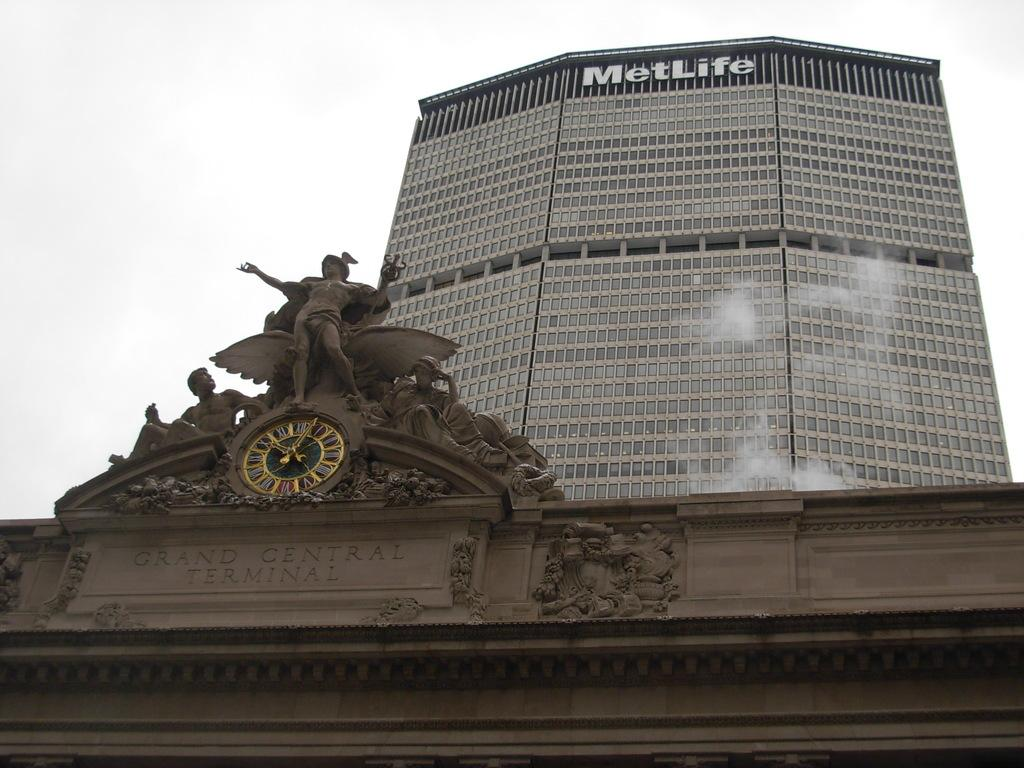What type of artwork can be seen in the image? There are sculptures in the image. What can be found on the wall of a building in the image? There is a clock on the wall of a building in the image. What is present on the wall of a building in the background of the image? There is a hoarding on the wall of a building in the background of the image. What is visible in the sky in the background of the image? There are clouds in the sky in the background of the image. What type of grain is being harvested in the image? There is no grain present in the image; it features sculptures, a clock, a hoarding, and clouds. Can you describe the air quality in the image? The image does not provide any information about the air quality; it only shows sculptures, a clock, a hoarding, and clouds. 